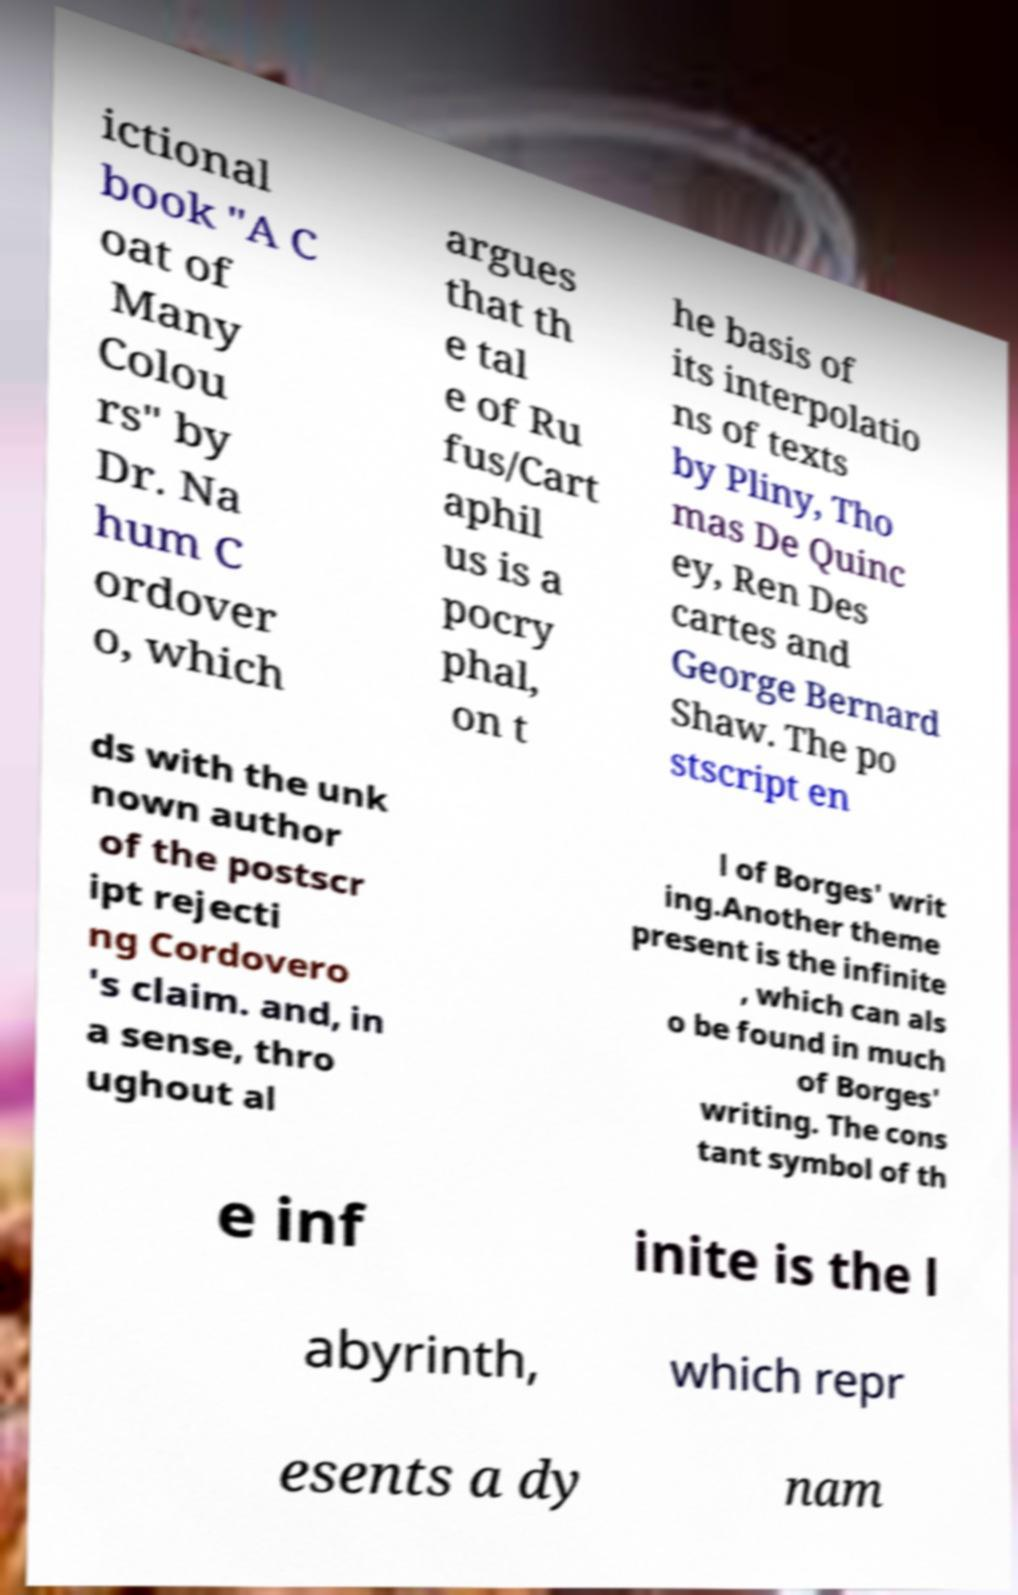Could you assist in decoding the text presented in this image and type it out clearly? ictional book "A C oat of Many Colou rs" by Dr. Na hum C ordover o, which argues that th e tal e of Ru fus/Cart aphil us is a pocry phal, on t he basis of its interpolatio ns of texts by Pliny, Tho mas De Quinc ey, Ren Des cartes and George Bernard Shaw. The po stscript en ds with the unk nown author of the postscr ipt rejecti ng Cordovero 's claim. and, in a sense, thro ughout al l of Borges' writ ing.Another theme present is the infinite , which can als o be found in much of Borges' writing. The cons tant symbol of th e inf inite is the l abyrinth, which repr esents a dy nam 